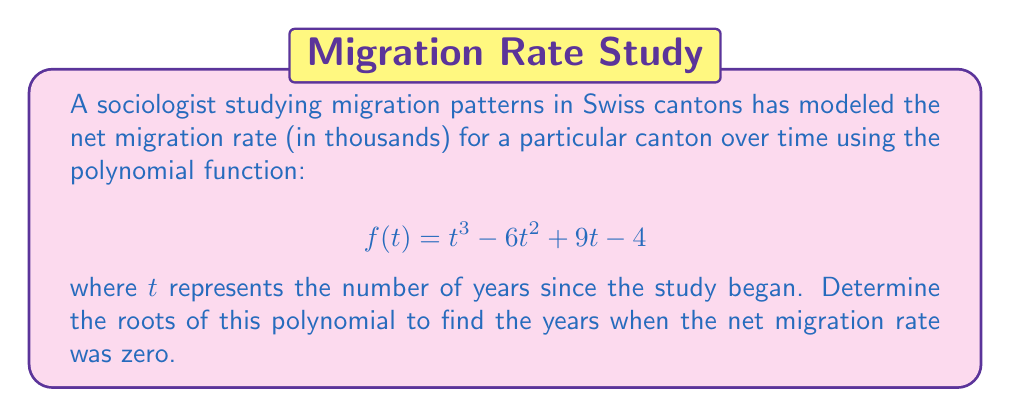Can you solve this math problem? To find the roots of the polynomial, we need to solve the equation:

$$t^3 - 6t^2 + 9t - 4 = 0$$

Let's approach this step-by-step:

1) First, we can try to factor out any common factors. In this case, there are none.

2) Next, we can check if there's a rational root using the rational root theorem. The possible rational roots are the factors of the constant term (4): ±1, ±2, ±4.

3) Testing these values, we find that $t = 1$ is a root:

   $f(1) = 1^3 - 6(1)^2 + 9(1) - 4 = 1 - 6 + 9 - 4 = 0$

4) Now we can factor out $(t-1)$:

   $t^3 - 6t^2 + 9t - 4 = (t-1)(t^2 - 5t + 4)$

5) We can solve the quadratic equation $t^2 - 5t + 4 = 0$ using the quadratic formula:

   $$t = \frac{-b \pm \sqrt{b^2 - 4ac}}{2a}$$

   Where $a=1$, $b=-5$, and $c=4$

6) Substituting these values:

   $$t = \frac{5 \pm \sqrt{25 - 16}}{2} = \frac{5 \pm 3}{2}$$

7) This gives us two more roots:

   $$t = \frac{5 + 3}{2} = 4$$ and $$t = \frac{5 - 3}{2} = 1$$

Therefore, the roots of the polynomial are 1 (twice) and 4.
Answer: The roots of the polynomial are $t = 1$ (with multiplicity 2) and $t = 4$. This means the net migration rate was zero at 1 year and 4 years after the study began. 